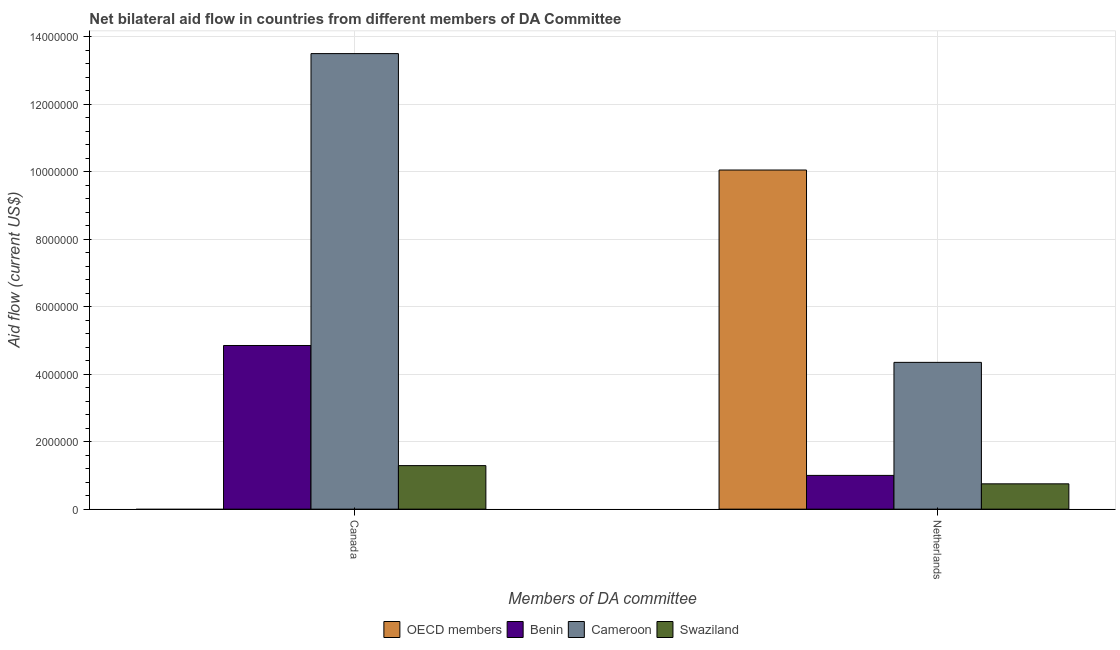Are the number of bars per tick equal to the number of legend labels?
Offer a very short reply. No. How many bars are there on the 2nd tick from the left?
Your response must be concise. 4. How many bars are there on the 1st tick from the right?
Make the answer very short. 4. What is the label of the 1st group of bars from the left?
Provide a short and direct response. Canada. What is the amount of aid given by netherlands in Cameroon?
Provide a succinct answer. 4.35e+06. Across all countries, what is the maximum amount of aid given by netherlands?
Provide a short and direct response. 1.00e+07. What is the total amount of aid given by canada in the graph?
Offer a very short reply. 1.96e+07. What is the difference between the amount of aid given by canada in Benin and that in Cameroon?
Ensure brevity in your answer.  -8.65e+06. What is the difference between the amount of aid given by canada in Cameroon and the amount of aid given by netherlands in OECD members?
Offer a very short reply. 3.45e+06. What is the average amount of aid given by netherlands per country?
Offer a terse response. 4.04e+06. What is the difference between the amount of aid given by canada and amount of aid given by netherlands in Cameroon?
Your answer should be compact. 9.15e+06. What is the ratio of the amount of aid given by netherlands in Swaziland to that in OECD members?
Offer a terse response. 0.07. In how many countries, is the amount of aid given by canada greater than the average amount of aid given by canada taken over all countries?
Your answer should be very brief. 1. Are all the bars in the graph horizontal?
Provide a succinct answer. No. What is the difference between two consecutive major ticks on the Y-axis?
Provide a succinct answer. 2.00e+06. Are the values on the major ticks of Y-axis written in scientific E-notation?
Offer a very short reply. No. Does the graph contain any zero values?
Ensure brevity in your answer.  Yes. How are the legend labels stacked?
Offer a very short reply. Horizontal. What is the title of the graph?
Offer a very short reply. Net bilateral aid flow in countries from different members of DA Committee. Does "Canada" appear as one of the legend labels in the graph?
Your answer should be compact. No. What is the label or title of the X-axis?
Provide a succinct answer. Members of DA committee. What is the label or title of the Y-axis?
Make the answer very short. Aid flow (current US$). What is the Aid flow (current US$) of OECD members in Canada?
Make the answer very short. 0. What is the Aid flow (current US$) of Benin in Canada?
Give a very brief answer. 4.85e+06. What is the Aid flow (current US$) of Cameroon in Canada?
Ensure brevity in your answer.  1.35e+07. What is the Aid flow (current US$) of Swaziland in Canada?
Give a very brief answer. 1.29e+06. What is the Aid flow (current US$) in OECD members in Netherlands?
Offer a terse response. 1.00e+07. What is the Aid flow (current US$) of Cameroon in Netherlands?
Your response must be concise. 4.35e+06. What is the Aid flow (current US$) in Swaziland in Netherlands?
Offer a terse response. 7.50e+05. Across all Members of DA committee, what is the maximum Aid flow (current US$) in OECD members?
Make the answer very short. 1.00e+07. Across all Members of DA committee, what is the maximum Aid flow (current US$) in Benin?
Offer a very short reply. 4.85e+06. Across all Members of DA committee, what is the maximum Aid flow (current US$) in Cameroon?
Make the answer very short. 1.35e+07. Across all Members of DA committee, what is the maximum Aid flow (current US$) in Swaziland?
Ensure brevity in your answer.  1.29e+06. Across all Members of DA committee, what is the minimum Aid flow (current US$) in Benin?
Make the answer very short. 1.00e+06. Across all Members of DA committee, what is the minimum Aid flow (current US$) in Cameroon?
Your answer should be very brief. 4.35e+06. Across all Members of DA committee, what is the minimum Aid flow (current US$) in Swaziland?
Provide a succinct answer. 7.50e+05. What is the total Aid flow (current US$) of OECD members in the graph?
Keep it short and to the point. 1.00e+07. What is the total Aid flow (current US$) of Benin in the graph?
Offer a terse response. 5.85e+06. What is the total Aid flow (current US$) in Cameroon in the graph?
Give a very brief answer. 1.78e+07. What is the total Aid flow (current US$) in Swaziland in the graph?
Ensure brevity in your answer.  2.04e+06. What is the difference between the Aid flow (current US$) of Benin in Canada and that in Netherlands?
Your answer should be compact. 3.85e+06. What is the difference between the Aid flow (current US$) in Cameroon in Canada and that in Netherlands?
Provide a succinct answer. 9.15e+06. What is the difference between the Aid flow (current US$) in Swaziland in Canada and that in Netherlands?
Ensure brevity in your answer.  5.40e+05. What is the difference between the Aid flow (current US$) of Benin in Canada and the Aid flow (current US$) of Cameroon in Netherlands?
Offer a terse response. 5.00e+05. What is the difference between the Aid flow (current US$) of Benin in Canada and the Aid flow (current US$) of Swaziland in Netherlands?
Offer a terse response. 4.10e+06. What is the difference between the Aid flow (current US$) of Cameroon in Canada and the Aid flow (current US$) of Swaziland in Netherlands?
Provide a succinct answer. 1.28e+07. What is the average Aid flow (current US$) in OECD members per Members of DA committee?
Provide a short and direct response. 5.02e+06. What is the average Aid flow (current US$) of Benin per Members of DA committee?
Offer a very short reply. 2.92e+06. What is the average Aid flow (current US$) of Cameroon per Members of DA committee?
Your response must be concise. 8.92e+06. What is the average Aid flow (current US$) in Swaziland per Members of DA committee?
Offer a very short reply. 1.02e+06. What is the difference between the Aid flow (current US$) of Benin and Aid flow (current US$) of Cameroon in Canada?
Your answer should be compact. -8.65e+06. What is the difference between the Aid flow (current US$) of Benin and Aid flow (current US$) of Swaziland in Canada?
Provide a short and direct response. 3.56e+06. What is the difference between the Aid flow (current US$) of Cameroon and Aid flow (current US$) of Swaziland in Canada?
Your answer should be very brief. 1.22e+07. What is the difference between the Aid flow (current US$) of OECD members and Aid flow (current US$) of Benin in Netherlands?
Make the answer very short. 9.05e+06. What is the difference between the Aid flow (current US$) of OECD members and Aid flow (current US$) of Cameroon in Netherlands?
Provide a short and direct response. 5.70e+06. What is the difference between the Aid flow (current US$) in OECD members and Aid flow (current US$) in Swaziland in Netherlands?
Offer a terse response. 9.30e+06. What is the difference between the Aid flow (current US$) of Benin and Aid flow (current US$) of Cameroon in Netherlands?
Give a very brief answer. -3.35e+06. What is the difference between the Aid flow (current US$) of Cameroon and Aid flow (current US$) of Swaziland in Netherlands?
Offer a terse response. 3.60e+06. What is the ratio of the Aid flow (current US$) of Benin in Canada to that in Netherlands?
Your answer should be compact. 4.85. What is the ratio of the Aid flow (current US$) of Cameroon in Canada to that in Netherlands?
Offer a terse response. 3.1. What is the ratio of the Aid flow (current US$) of Swaziland in Canada to that in Netherlands?
Your answer should be compact. 1.72. What is the difference between the highest and the second highest Aid flow (current US$) of Benin?
Provide a short and direct response. 3.85e+06. What is the difference between the highest and the second highest Aid flow (current US$) in Cameroon?
Keep it short and to the point. 9.15e+06. What is the difference between the highest and the second highest Aid flow (current US$) in Swaziland?
Your answer should be very brief. 5.40e+05. What is the difference between the highest and the lowest Aid flow (current US$) of OECD members?
Ensure brevity in your answer.  1.00e+07. What is the difference between the highest and the lowest Aid flow (current US$) in Benin?
Your response must be concise. 3.85e+06. What is the difference between the highest and the lowest Aid flow (current US$) in Cameroon?
Offer a very short reply. 9.15e+06. What is the difference between the highest and the lowest Aid flow (current US$) of Swaziland?
Ensure brevity in your answer.  5.40e+05. 